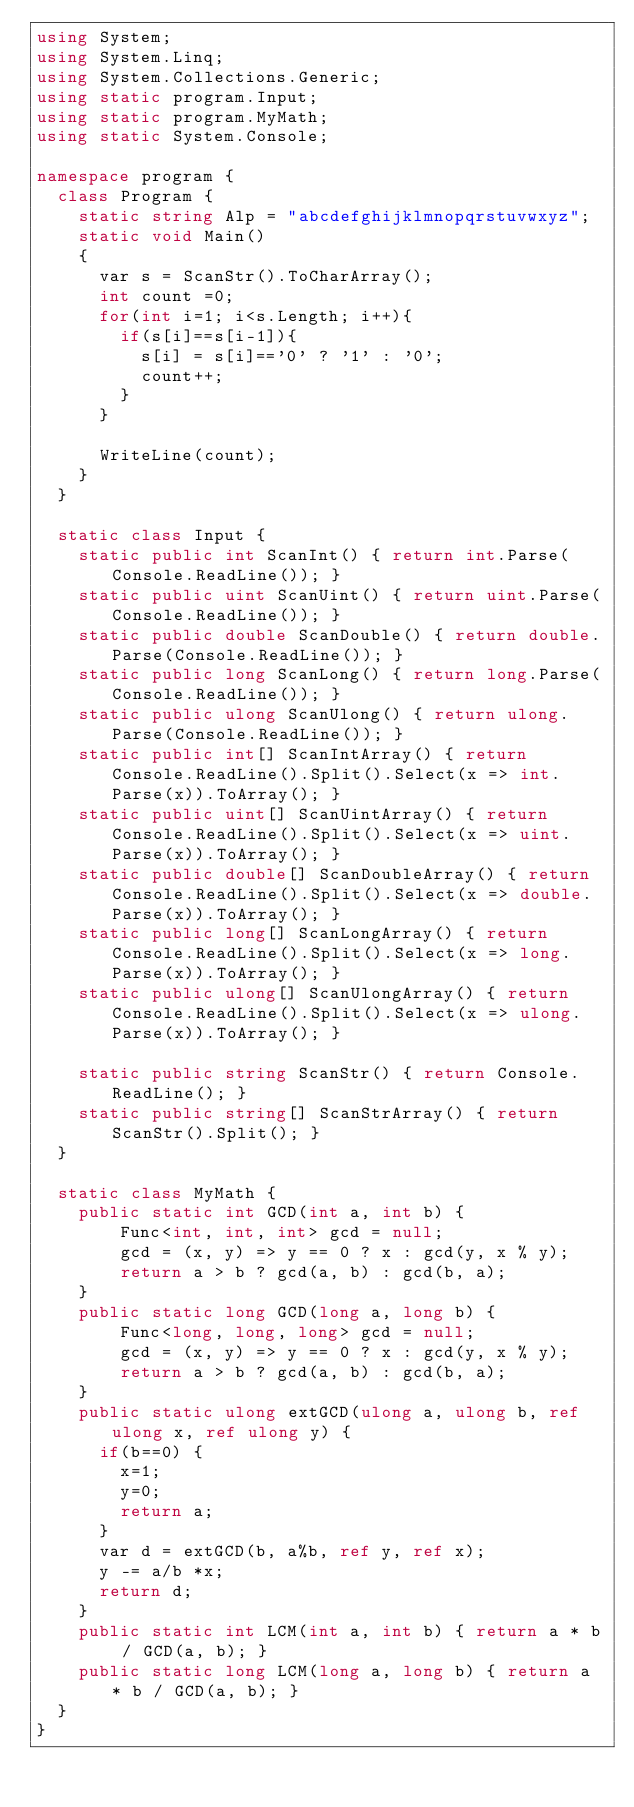<code> <loc_0><loc_0><loc_500><loc_500><_C#_>using System;
using System.Linq;
using System.Collections.Generic;
using static program.Input;
using static program.MyMath;
using static System.Console;

namespace program {
  class Program {
    static string Alp = "abcdefghijklmnopqrstuvwxyz";
    static void Main()
    {
      var s = ScanStr().ToCharArray();
      int count =0;
      for(int i=1; i<s.Length; i++){
        if(s[i]==s[i-1]){
          s[i] = s[i]=='0' ? '1' : '0';
          count++;
        }
      }
      
      WriteLine(count);
    }
  }
  
  static class Input {
    static public int ScanInt() { return int.Parse(Console.ReadLine()); }
    static public uint ScanUint() { return uint.Parse(Console.ReadLine()); }
    static public double ScanDouble() { return double.Parse(Console.ReadLine()); }
    static public long ScanLong() { return long.Parse(Console.ReadLine()); }
    static public ulong ScanUlong() { return ulong.Parse(Console.ReadLine()); }
    static public int[] ScanIntArray() { return Console.ReadLine().Split().Select(x => int.Parse(x)).ToArray(); }
    static public uint[] ScanUintArray() { return Console.ReadLine().Split().Select(x => uint.Parse(x)).ToArray(); }
    static public double[] ScanDoubleArray() { return Console.ReadLine().Split().Select(x => double.Parse(x)).ToArray(); }
    static public long[] ScanLongArray() { return Console.ReadLine().Split().Select(x => long.Parse(x)).ToArray(); }
    static public ulong[] ScanUlongArray() { return Console.ReadLine().Split().Select(x => ulong.Parse(x)).ToArray(); }

    static public string ScanStr() { return Console.ReadLine(); }
    static public string[] ScanStrArray() { return ScanStr().Split(); }
  }
  
  static class MyMath {
    public static int GCD(int a, int b) {
        Func<int, int, int> gcd = null;
        gcd = (x, y) => y == 0 ? x : gcd(y, x % y);
        return a > b ? gcd(a, b) : gcd(b, a);
    }
    public static long GCD(long a, long b) {
        Func<long, long, long> gcd = null;
        gcd = (x, y) => y == 0 ? x : gcd(y, x % y);
        return a > b ? gcd(a, b) : gcd(b, a);
    }
    public static ulong extGCD(ulong a, ulong b, ref ulong x, ref ulong y) {
      if(b==0) {
        x=1; 
        y=0;
        return a;
      }
      var d = extGCD(b, a%b, ref y, ref x);
      y -= a/b *x;
      return d;
    }
    public static int LCM(int a, int b) { return a * b / GCD(a, b); }
    public static long LCM(long a, long b) { return a * b / GCD(a, b); }
  }
}
</code> 